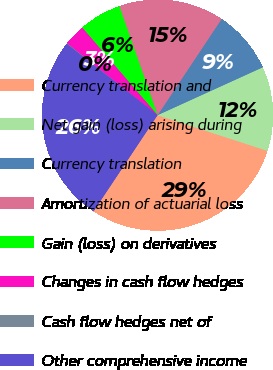<chart> <loc_0><loc_0><loc_500><loc_500><pie_chart><fcel>Currency translation and<fcel>Net gain (loss) arising during<fcel>Currency translation<fcel>Amortization of actuarial loss<fcel>Gain (loss) on derivatives<fcel>Changes in cash flow hedges<fcel>Cash flow hedges net of<fcel>Other comprehensive income<nl><fcel>29.35%<fcel>11.79%<fcel>8.86%<fcel>14.72%<fcel>5.94%<fcel>3.01%<fcel>0.08%<fcel>26.25%<nl></chart> 